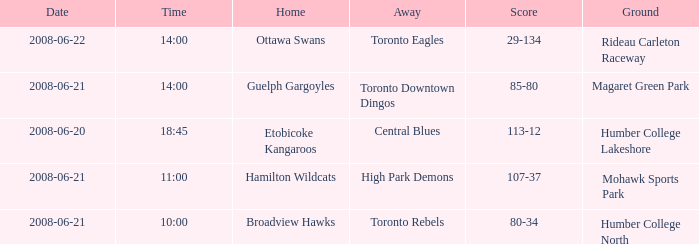What does the ground refer to on the date 2008-06-20? Humber College Lakeshore. 